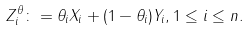Convert formula to latex. <formula><loc_0><loc_0><loc_500><loc_500>Z _ { i } ^ { \theta } \colon = \theta _ { i } X _ { i } + ( 1 - \theta _ { i } ) Y _ { i } , 1 \leq i \leq n .</formula> 